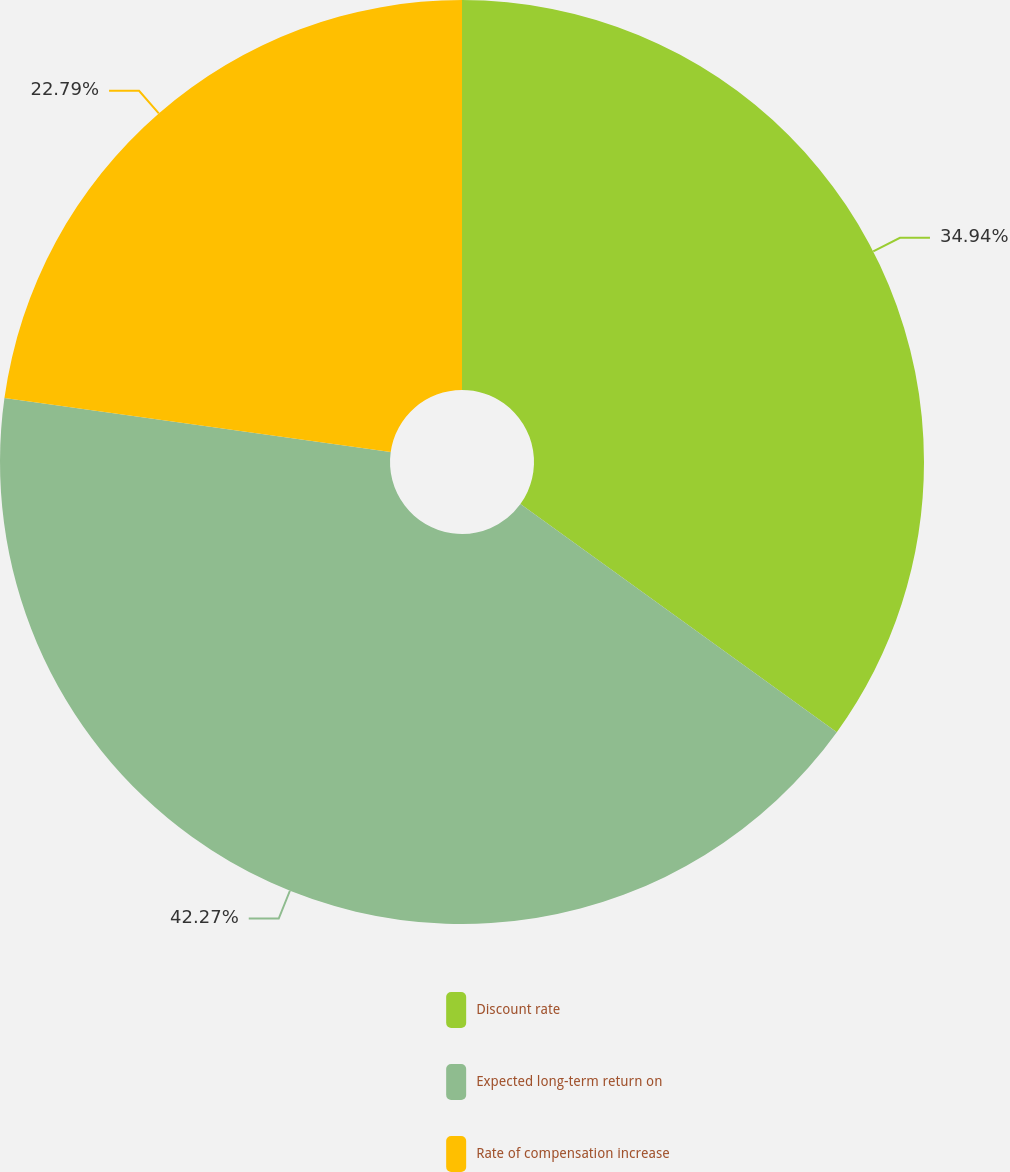<chart> <loc_0><loc_0><loc_500><loc_500><pie_chart><fcel>Discount rate<fcel>Expected long-term return on<fcel>Rate of compensation increase<nl><fcel>34.94%<fcel>42.27%<fcel>22.79%<nl></chart> 